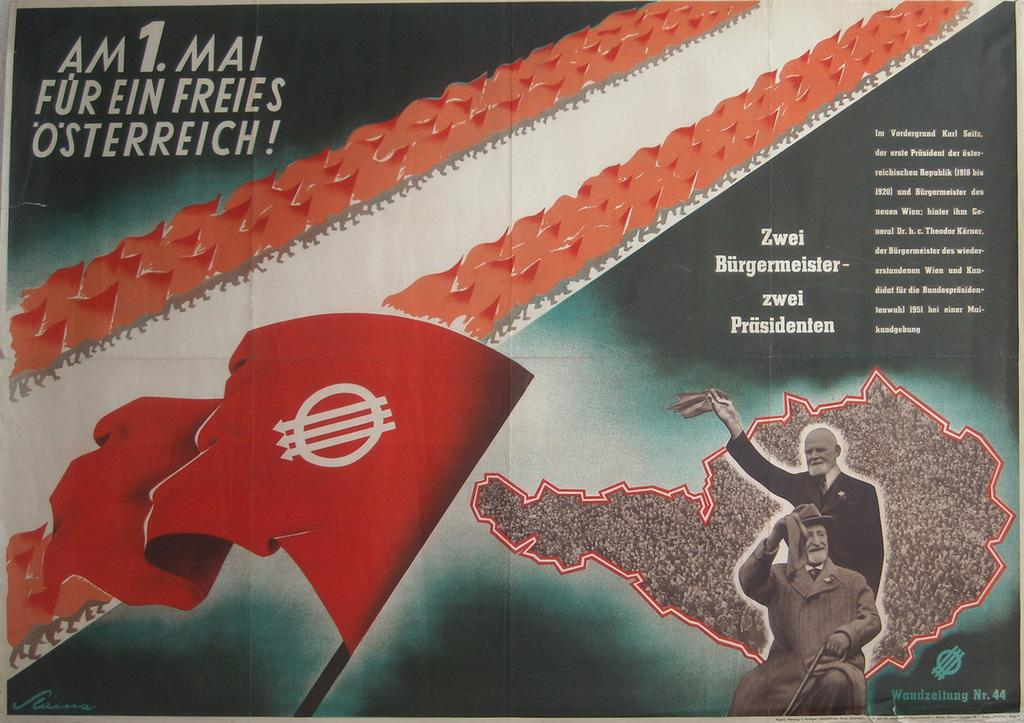<image>
Describe the image concisely. A magazine open to a page that says AM 1 Ma! Fur Ein Freies Osterriech! 